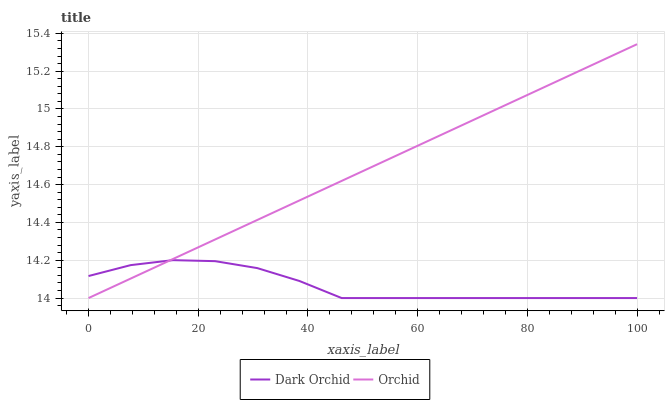Does Dark Orchid have the minimum area under the curve?
Answer yes or no. Yes. Does Orchid have the maximum area under the curve?
Answer yes or no. Yes. Does Orchid have the minimum area under the curve?
Answer yes or no. No. Is Orchid the smoothest?
Answer yes or no. Yes. Is Dark Orchid the roughest?
Answer yes or no. Yes. Is Orchid the roughest?
Answer yes or no. No. Does Orchid have the highest value?
Answer yes or no. Yes. Does Orchid intersect Dark Orchid?
Answer yes or no. Yes. Is Orchid less than Dark Orchid?
Answer yes or no. No. Is Orchid greater than Dark Orchid?
Answer yes or no. No. 